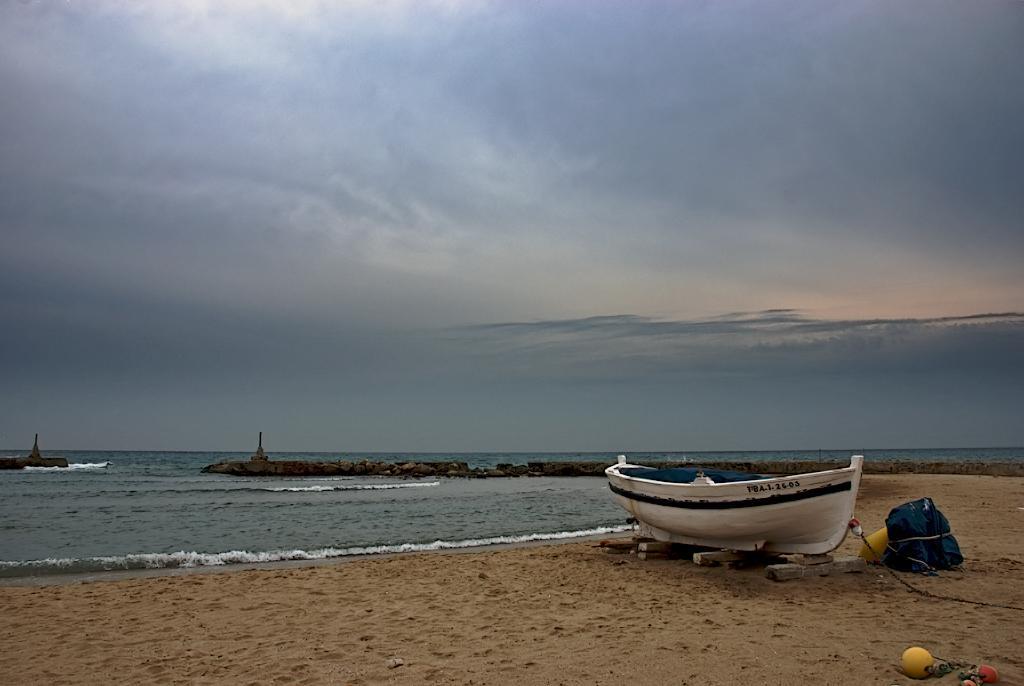In one or two sentences, can you explain what this image depicts? There is a white color boat on the sea shore. It is on wooden logs. Near to that there is a bag. In the back there is water, rocks and sky. 